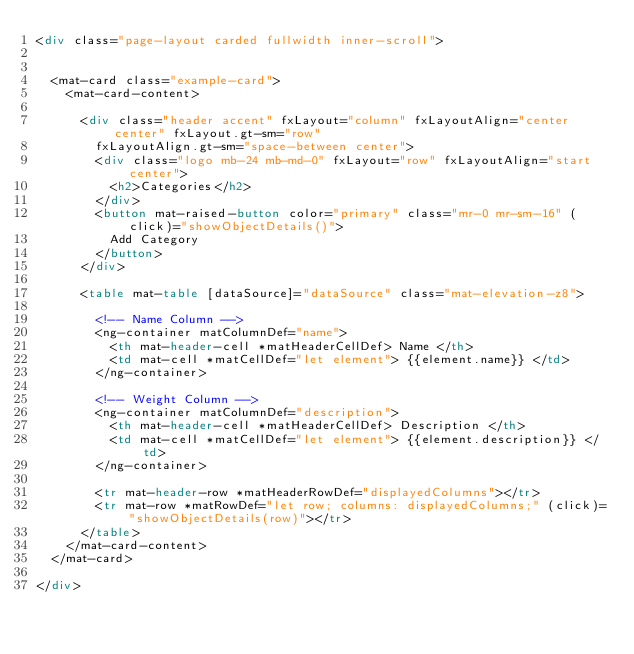<code> <loc_0><loc_0><loc_500><loc_500><_HTML_><div class="page-layout carded fullwidth inner-scroll">


  <mat-card class="example-card">
    <mat-card-content>

      <div class="header accent" fxLayout="column" fxLayoutAlign="center center" fxLayout.gt-sm="row"
        fxLayoutAlign.gt-sm="space-between center">
        <div class="logo mb-24 mb-md-0" fxLayout="row" fxLayoutAlign="start center">
          <h2>Categories</h2>
        </div>
        <button mat-raised-button color="primary" class="mr-0 mr-sm-16" (click)="showObjectDetails()">
          Add Category
        </button>
      </div>

      <table mat-table [dataSource]="dataSource" class="mat-elevation-z8">

        <!-- Name Column -->
        <ng-container matColumnDef="name">
          <th mat-header-cell *matHeaderCellDef> Name </th>
          <td mat-cell *matCellDef="let element"> {{element.name}} </td>
        </ng-container>

        <!-- Weight Column -->
        <ng-container matColumnDef="description">
          <th mat-header-cell *matHeaderCellDef> Description </th>
          <td mat-cell *matCellDef="let element"> {{element.description}} </td>
        </ng-container>

        <tr mat-header-row *matHeaderRowDef="displayedColumns"></tr>
        <tr mat-row *matRowDef="let row; columns: displayedColumns;" (click)="showObjectDetails(row)"></tr>
      </table>
    </mat-card-content>
  </mat-card>

</div></code> 